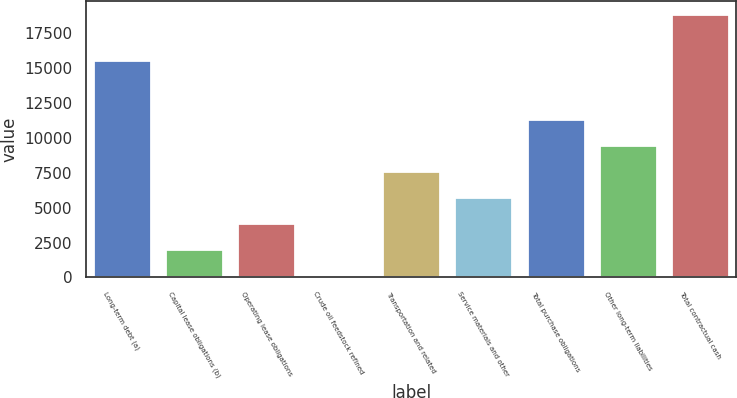Convert chart. <chart><loc_0><loc_0><loc_500><loc_500><bar_chart><fcel>Long-term debt (a)<fcel>Capital lease obligations (b)<fcel>Operating lease obligations<fcel>Crude oil feedstock refined<fcel>Transportation and related<fcel>Service materials and other<fcel>Total purchase obligations<fcel>Other long-term liabilities<fcel>Total contractual cash<nl><fcel>15550<fcel>1999.8<fcel>3873.6<fcel>126<fcel>7621.2<fcel>5747.4<fcel>11368.8<fcel>9495<fcel>18864<nl></chart> 